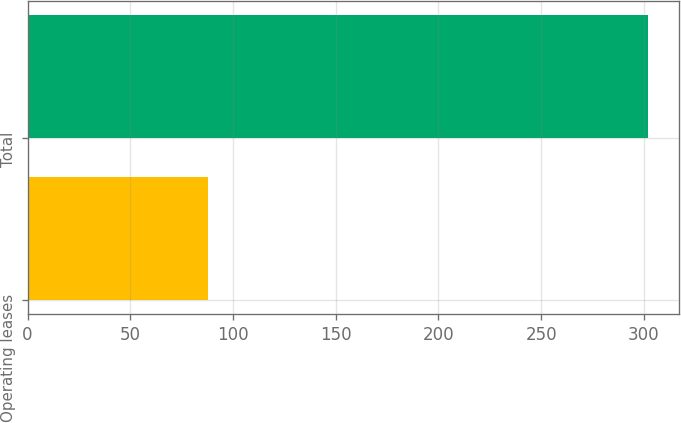Convert chart. <chart><loc_0><loc_0><loc_500><loc_500><bar_chart><fcel>Operating leases<fcel>Total<nl><fcel>87.7<fcel>302<nl></chart> 